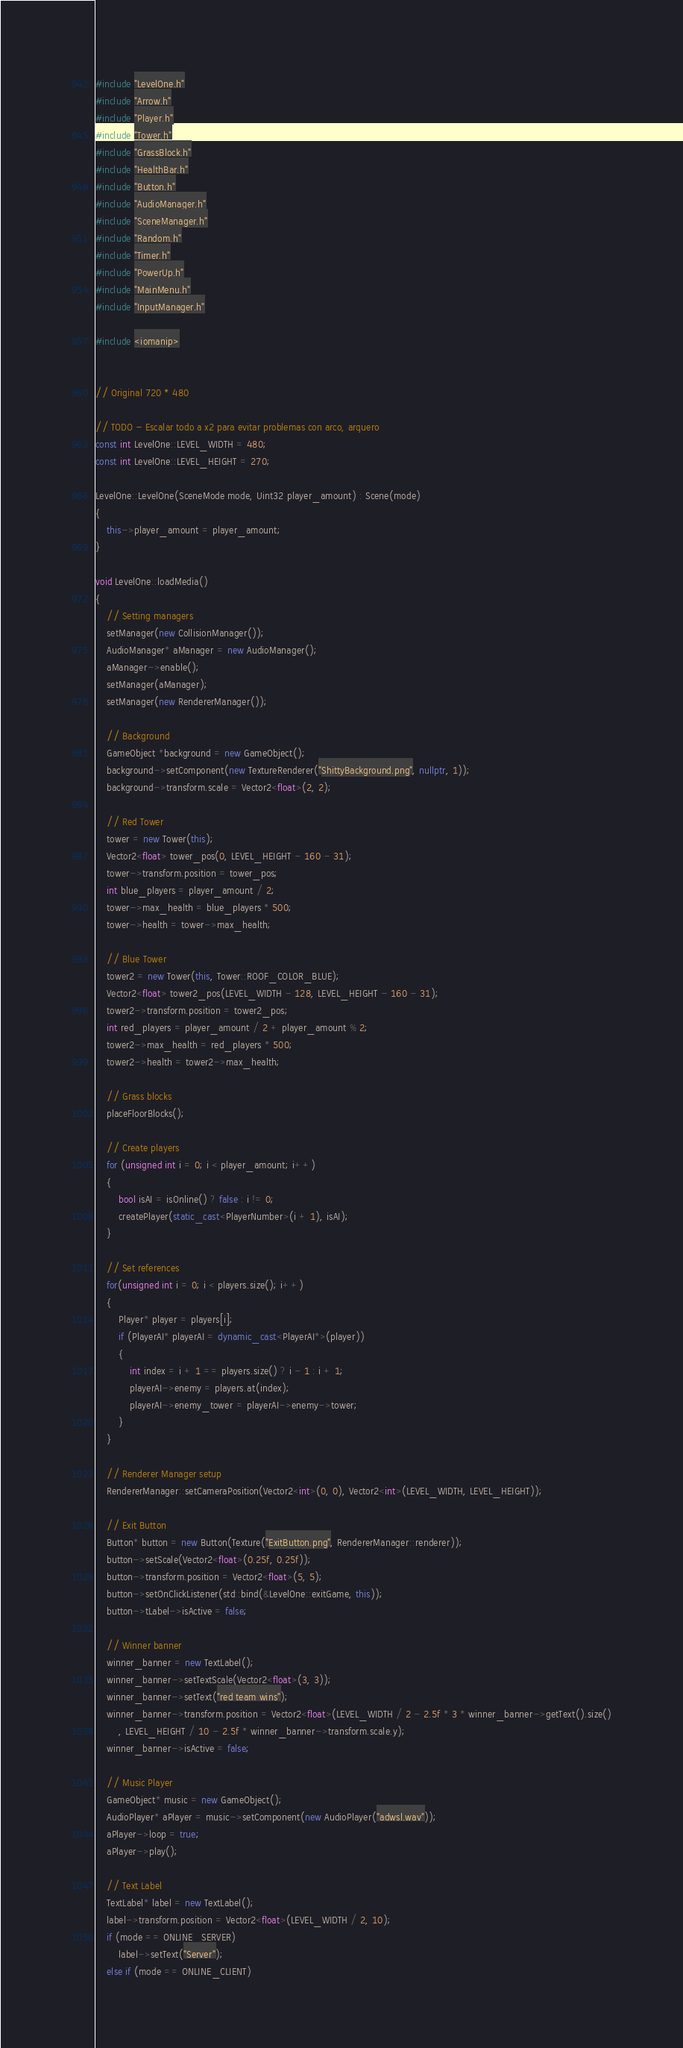<code> <loc_0><loc_0><loc_500><loc_500><_C++_>#include "LevelOne.h"
#include "Arrow.h"
#include "Player.h"
#include "Tower.h"
#include "GrassBlock.h"
#include "HealthBar.h"
#include "Button.h"
#include "AudioManager.h"
#include "SceneManager.h"
#include "Random.h"
#include "Timer.h"
#include "PowerUp.h"
#include "MainMenu.h"
#include "InputManager.h"

#include <iomanip>


// Original 720 * 480

// TODO - Escalar todo a x2 para evitar problemas con arco, arquero
const int LevelOne::LEVEL_WIDTH = 480;
const int LevelOne::LEVEL_HEIGHT = 270;

LevelOne::LevelOne(SceneMode mode, Uint32 player_amount) : Scene(mode)
{
	this->player_amount = player_amount;
}

void LevelOne::loadMedia()
{
	// Setting managers
	setManager(new CollisionManager());
	AudioManager* aManager = new AudioManager();
	aManager->enable();
	setManager(aManager);
	setManager(new RendererManager());

	// Background
	GameObject *background = new GameObject();
	background->setComponent(new TextureRenderer("ShittyBackground.png", nullptr, 1));
	background->transform.scale = Vector2<float>(2, 2);

	// Red Tower
	tower = new Tower(this);
	Vector2<float> tower_pos(0, LEVEL_HEIGHT - 160 - 31);
	tower->transform.position = tower_pos;
	int blue_players = player_amount / 2;
	tower->max_health = blue_players * 500;
	tower->health = tower->max_health;

	// Blue Tower
	tower2 = new Tower(this, Tower::ROOF_COLOR_BLUE);
	Vector2<float> tower2_pos(LEVEL_WIDTH - 128, LEVEL_HEIGHT - 160 - 31);
	tower2->transform.position = tower2_pos;
	int red_players = player_amount / 2 + player_amount % 2;
	tower2->max_health = red_players * 500;
	tower2->health = tower2->max_health;

	// Grass blocks
	placeFloorBlocks();

	// Create players
	for (unsigned int i = 0; i < player_amount; i++)
	{
		bool isAI = isOnline() ? false : i != 0;
		createPlayer(static_cast<PlayerNumber>(i + 1), isAI);
	}

	// Set references
	for(unsigned int i = 0; i < players.size(); i++)
	{
		Player* player = players[i];
		if (PlayerAI* playerAI = dynamic_cast<PlayerAI*>(player))
		{
			int index = i + 1 == players.size() ? i - 1 : i + 1;
			playerAI->enemy = players.at(index);
			playerAI->enemy_tower = playerAI->enemy->tower;
		}
	}

	// Renderer Manager setup
	RendererManager::setCameraPosition(Vector2<int>(0, 0), Vector2<int>(LEVEL_WIDTH, LEVEL_HEIGHT));

	// Exit Button
	Button* button = new Button(Texture("ExitButton.png", RendererManager::renderer));
	button->setScale(Vector2<float>(0.25f, 0.25f));
	button->transform.position = Vector2<float>(5, 5);
	button->setOnClickListener(std::bind(&LevelOne::exitGame, this));
	button->tLabel->isActive = false;

	// Winner banner
	winner_banner = new TextLabel();
	winner_banner->setTextScale(Vector2<float>(3, 3));
	winner_banner->setText("red team wins");
	winner_banner->transform.position = Vector2<float>(LEVEL_WIDTH / 2 - 2.5f * 3 * winner_banner->getText().size()
		, LEVEL_HEIGHT / 10 - 2.5f * winner_banner->transform.scale.y);
	winner_banner->isActive = false;

	// Music Player
	GameObject* music = new GameObject();
	AudioPlayer* aPlayer = music->setComponent(new AudioPlayer("adwsl.wav"));
	aPlayer->loop = true;
	aPlayer->play();

	// Text Label
	TextLabel* label = new TextLabel();
	label->transform.position = Vector2<float>(LEVEL_WIDTH / 2, 10);
	if (mode == ONLINE_SERVER)
		label->setText("Server");
	else if (mode == ONLINE_CLIENT)</code> 